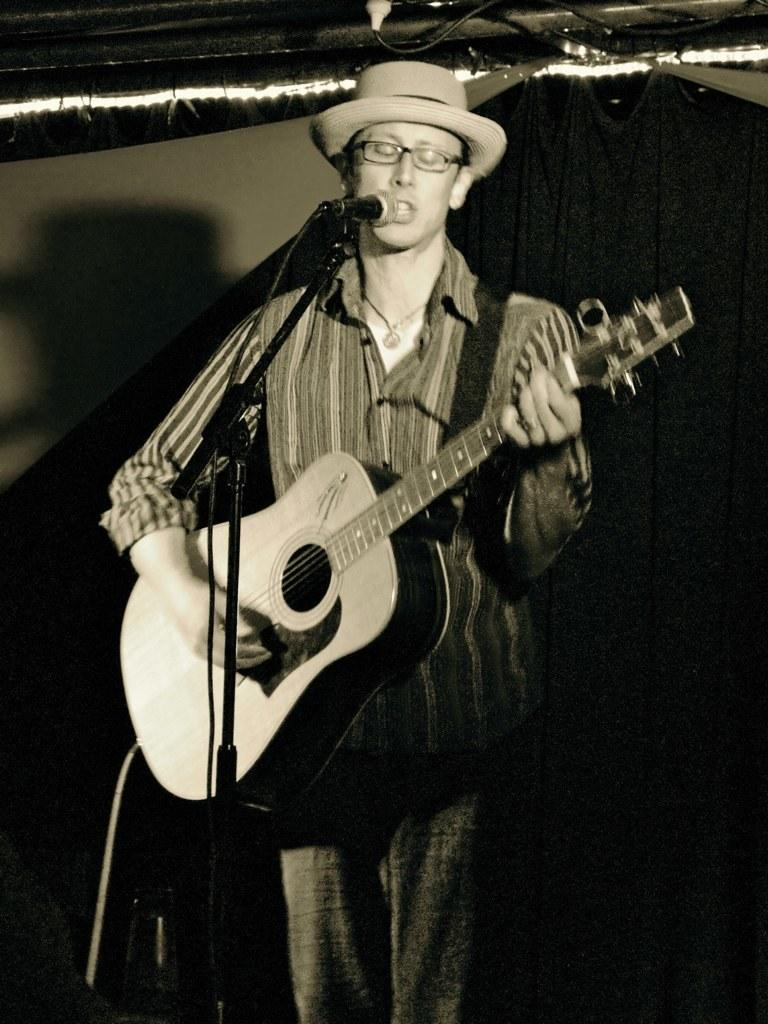What is the main subject of the picture? The main subject of the picture is a man. What is the man wearing on his head? The man is wearing a hat. What is the man doing in front of the microphone? The man is singing and playing a guitar. What is the color scheme of the picture? The picture is in black and white. What accessory is the man wearing on his face? The man is wearing spectacles. What type of plants can be seen growing near the microphone in the image? There are no plants visible in the image; it features a man singing and playing a guitar in front of a microphone. What reward is the man receiving for his performance in the image? There is no indication of a reward in the image; it simply shows the man singing and playing a guitar. 